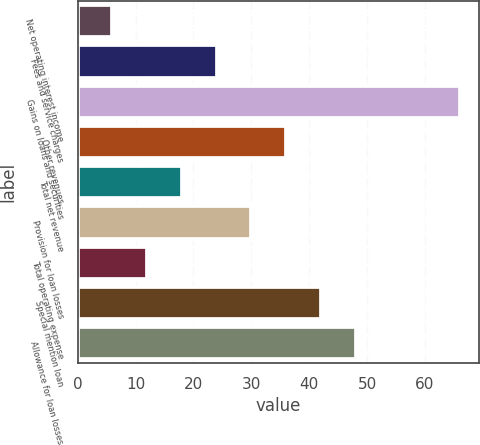Convert chart. <chart><loc_0><loc_0><loc_500><loc_500><bar_chart><fcel>Net operating interest income<fcel>Fees and service charges<fcel>Gains on loans and securities<fcel>Other revenues<fcel>Total net revenue<fcel>Provision for loan losses<fcel>Total operating expense<fcel>Special mention loan<fcel>Allowance for loan losses<nl><fcel>6<fcel>24<fcel>66<fcel>36<fcel>18<fcel>30<fcel>12<fcel>42<fcel>48<nl></chart> 